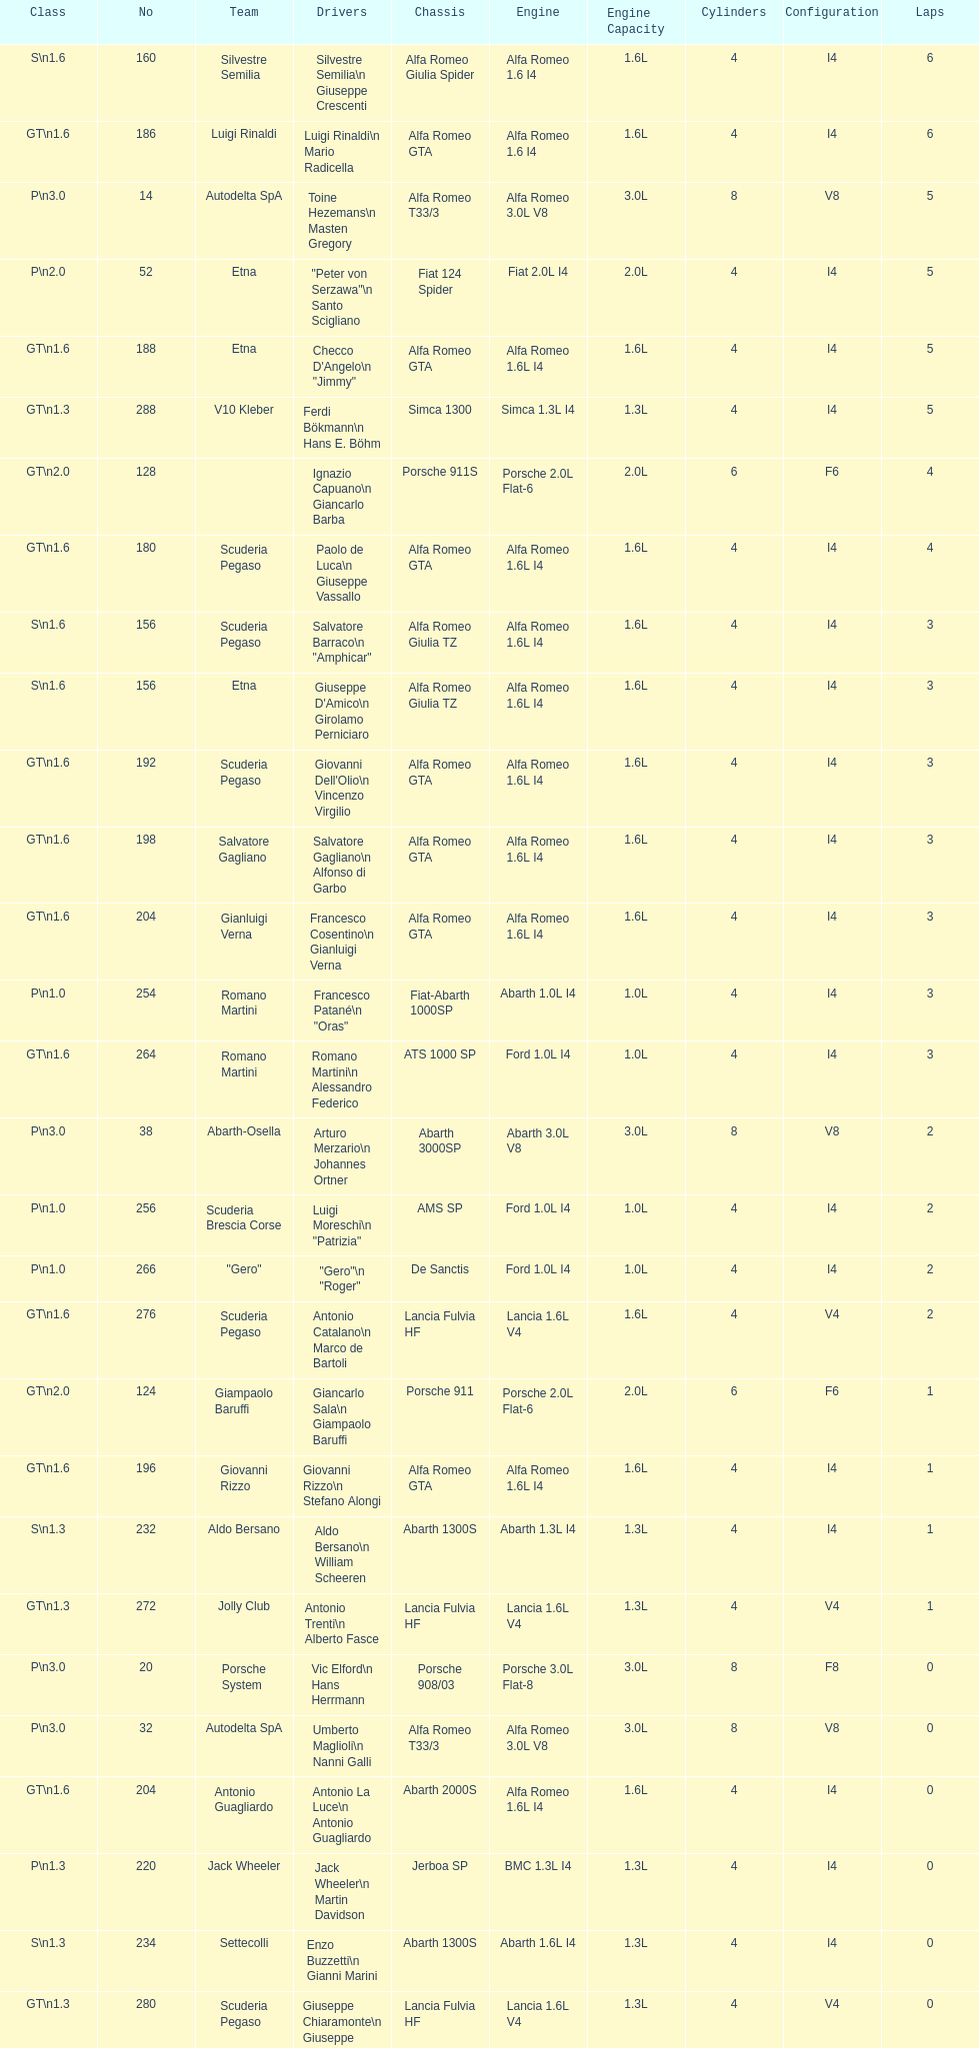Could you help me parse every detail presented in this table? {'header': ['Class', 'No', 'Team', 'Drivers', 'Chassis', 'Engine', 'Engine Capacity', 'Cylinders', 'Configuration', 'Laps'], 'rows': [['S\\n1.6', '160', 'Silvestre Semilia', 'Silvestre Semilia\\n Giuseppe Crescenti', 'Alfa Romeo Giulia Spider', 'Alfa Romeo 1.6 I4', '1.6L', '4', 'I4', '6'], ['GT\\n1.6', '186', 'Luigi Rinaldi', 'Luigi Rinaldi\\n Mario Radicella', 'Alfa Romeo GTA', 'Alfa Romeo 1.6 I4', '1.6L', '4', 'I4', '6'], ['P\\n3.0', '14', 'Autodelta SpA', 'Toine Hezemans\\n Masten Gregory', 'Alfa Romeo T33/3', 'Alfa Romeo 3.0L V8', '3.0L', '8', 'V8', '5'], ['P\\n2.0', '52', 'Etna', '"Peter von Serzawa"\\n Santo Scigliano', 'Fiat 124 Spider', 'Fiat 2.0L I4', '2.0L', '4', 'I4', '5'], ['GT\\n1.6', '188', 'Etna', 'Checco D\'Angelo\\n "Jimmy"', 'Alfa Romeo GTA', 'Alfa Romeo 1.6L I4', '1.6L', '4', 'I4', '5'], ['GT\\n1.3', '288', 'V10 Kleber', 'Ferdi Bökmann\\n Hans E. Böhm', 'Simca 1300', 'Simca 1.3L I4', '1.3L', '4', 'I4', '5'], ['GT\\n2.0', '128', '', 'Ignazio Capuano\\n Giancarlo Barba', 'Porsche 911S', 'Porsche 2.0L Flat-6', '2.0L', '6', 'F6', '4'], ['GT\\n1.6', '180', 'Scuderia Pegaso', 'Paolo de Luca\\n Giuseppe Vassallo', 'Alfa Romeo GTA', 'Alfa Romeo 1.6L I4', '1.6L', '4', 'I4', '4'], ['S\\n1.6', '156', 'Scuderia Pegaso', 'Salvatore Barraco\\n "Amphicar"', 'Alfa Romeo Giulia TZ', 'Alfa Romeo 1.6L I4', '1.6L', '4', 'I4', '3'], ['S\\n1.6', '156', 'Etna', "Giuseppe D'Amico\\n Girolamo Perniciaro", 'Alfa Romeo Giulia TZ', 'Alfa Romeo 1.6L I4', '1.6L', '4', 'I4', '3'], ['GT\\n1.6', '192', 'Scuderia Pegaso', "Giovanni Dell'Olio\\n Vincenzo Virgilio", 'Alfa Romeo GTA', 'Alfa Romeo 1.6L I4', '1.6L', '4', 'I4', '3'], ['GT\\n1.6', '198', 'Salvatore Gagliano', 'Salvatore Gagliano\\n Alfonso di Garbo', 'Alfa Romeo GTA', 'Alfa Romeo 1.6L I4', '1.6L', '4', 'I4', '3'], ['GT\\n1.6', '204', 'Gianluigi Verna', 'Francesco Cosentino\\n Gianluigi Verna', 'Alfa Romeo GTA', 'Alfa Romeo 1.6L I4', '1.6L', '4', 'I4', '3'], ['P\\n1.0', '254', 'Romano Martini', 'Francesco Patané\\n "Oras"', 'Fiat-Abarth 1000SP', 'Abarth 1.0L I4', '1.0L', '4', 'I4', '3'], ['GT\\n1.6', '264', 'Romano Martini', 'Romano Martini\\n Alessandro Federico', 'ATS 1000 SP', 'Ford 1.0L I4', '1.0L', '4', 'I4', '3'], ['P\\n3.0', '38', 'Abarth-Osella', 'Arturo Merzario\\n Johannes Ortner', 'Abarth 3000SP', 'Abarth 3.0L V8', '3.0L', '8', 'V8', '2'], ['P\\n1.0', '256', 'Scuderia Brescia Corse', 'Luigi Moreschi\\n "Patrizia"', 'AMS SP', 'Ford 1.0L I4', '1.0L', '4', 'I4', '2'], ['P\\n1.0', '266', '"Gero"', '"Gero"\\n "Roger"', 'De Sanctis', 'Ford 1.0L I4', '1.0L', '4', 'I4', '2'], ['GT\\n1.6', '276', 'Scuderia Pegaso', 'Antonio Catalano\\n Marco de Bartoli', 'Lancia Fulvia HF', 'Lancia 1.6L V4', '1.6L', '4', 'V4', '2'], ['GT\\n2.0', '124', 'Giampaolo Baruffi', 'Giancarlo Sala\\n Giampaolo Baruffi', 'Porsche 911', 'Porsche 2.0L Flat-6', '2.0L', '6', 'F6', '1'], ['GT\\n1.6', '196', 'Giovanni Rizzo', 'Giovanni Rizzo\\n Stefano Alongi', 'Alfa Romeo GTA', 'Alfa Romeo 1.6L I4', '1.6L', '4', 'I4', '1'], ['S\\n1.3', '232', 'Aldo Bersano', 'Aldo Bersano\\n William Scheeren', 'Abarth 1300S', 'Abarth 1.3L I4', '1.3L', '4', 'I4', '1'], ['GT\\n1.3', '272', 'Jolly Club', 'Antonio Trenti\\n Alberto Fasce', 'Lancia Fulvia HF', 'Lancia 1.6L V4', '1.3L', '4', 'V4', '1'], ['P\\n3.0', '20', 'Porsche System', 'Vic Elford\\n Hans Herrmann', 'Porsche 908/03', 'Porsche 3.0L Flat-8', '3.0L', '8', 'F8', '0'], ['P\\n3.0', '32', 'Autodelta SpA', 'Umberto Maglioli\\n Nanni Galli', 'Alfa Romeo T33/3', 'Alfa Romeo 3.0L V8', '3.0L', '8', 'V8', '0'], ['GT\\n1.6', '204', 'Antonio Guagliardo', 'Antonio La Luce\\n Antonio Guagliardo', 'Abarth 2000S', 'Alfa Romeo 1.6L I4', '1.6L', '4', 'I4', '0'], ['P\\n1.3', '220', 'Jack Wheeler', 'Jack Wheeler\\n Martin Davidson', 'Jerboa SP', 'BMC 1.3L I4', '1.3L', '4', 'I4', '0'], ['S\\n1.3', '234', 'Settecolli', 'Enzo Buzzetti\\n Gianni Marini', 'Abarth 1300S', 'Abarth 1.6L I4', '1.3L', '4', 'I4', '0'], ['GT\\n1.3', '280', 'Scuderia Pegaso', 'Giuseppe Chiaramonte\\n Giuseppe Spatafora', 'Lancia Fulvia HF', 'Lancia 1.6L V4', '1.3L', '4', 'V4', '0']]} His nickname is "jimmy," but what is his full name? Checco D'Angelo. 